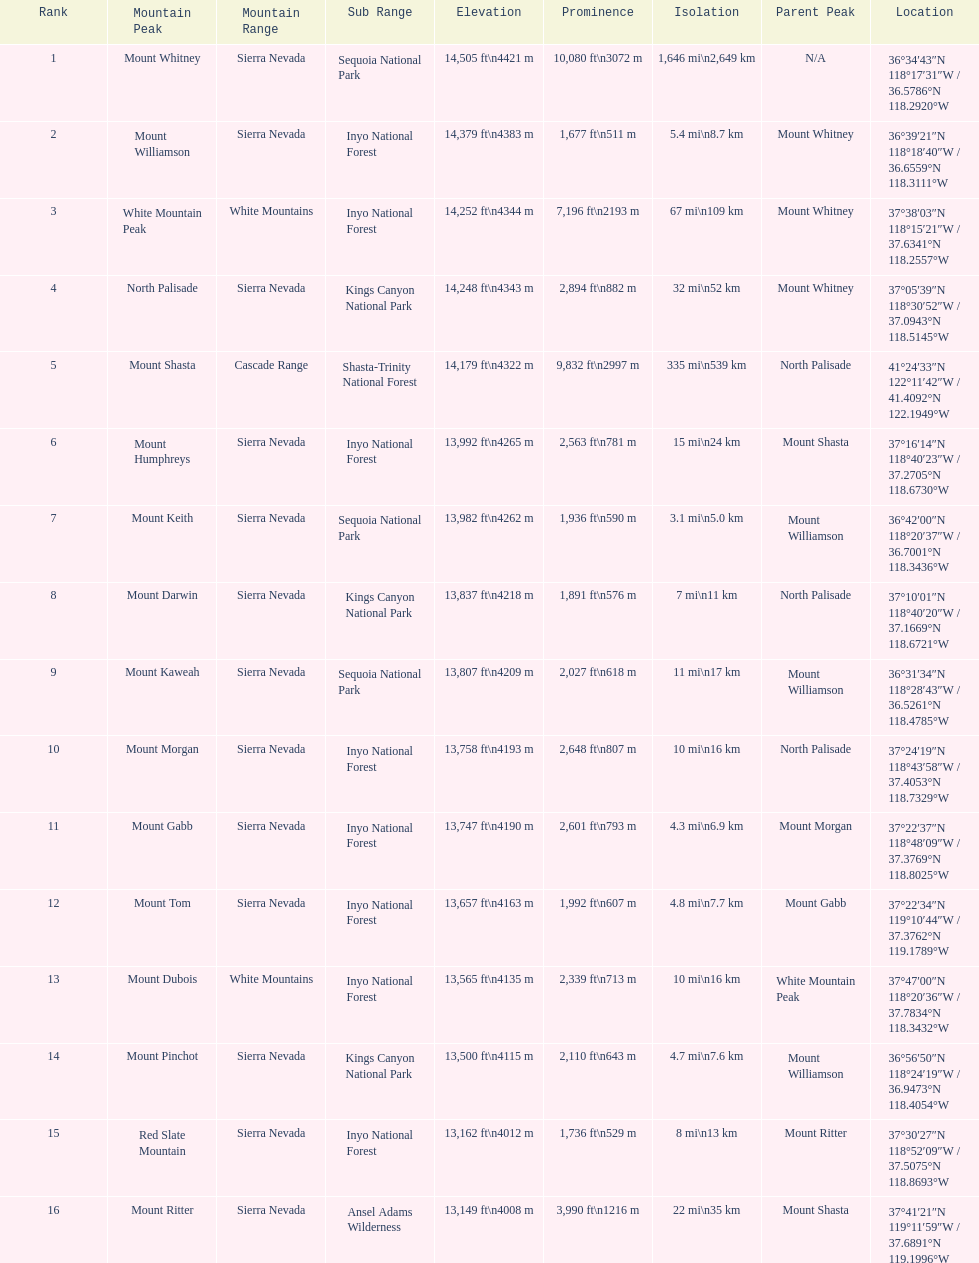Which is taller, mount humphreys or mount kaweah. Mount Humphreys. 